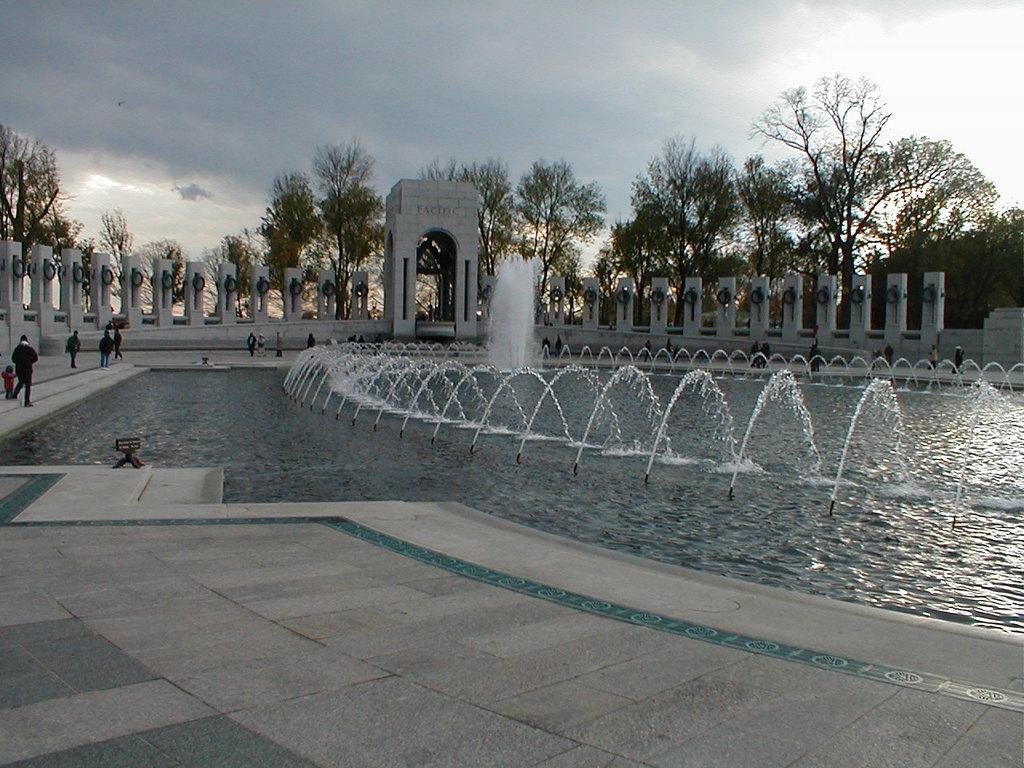Describe this image in one or two sentences. At the bottom of the image there is a floor. Behind the floor there is water with fountains. In the background there are pillars and also there is an arch. Behind the arch there are trees. At the top of the image there is a sky with clouds. 